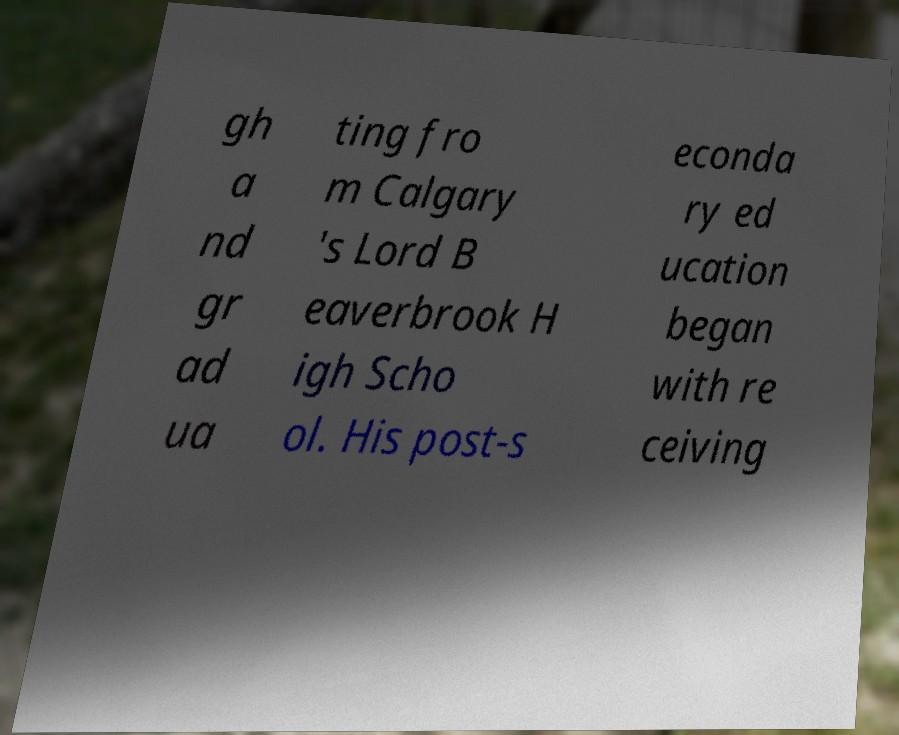Please identify and transcribe the text found in this image. gh a nd gr ad ua ting fro m Calgary 's Lord B eaverbrook H igh Scho ol. His post-s econda ry ed ucation began with re ceiving 